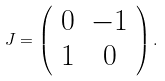<formula> <loc_0><loc_0><loc_500><loc_500>J = \left ( \begin{array} { c c c c } 0 & - 1 \\ 1 & 0 \end{array} \right ) .</formula> 